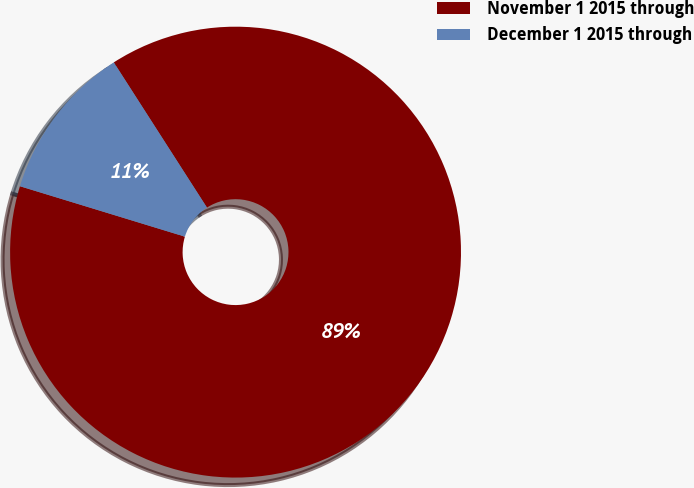Convert chart to OTSL. <chart><loc_0><loc_0><loc_500><loc_500><pie_chart><fcel>November 1 2015 through<fcel>December 1 2015 through<nl><fcel>88.8%<fcel>11.2%<nl></chart> 